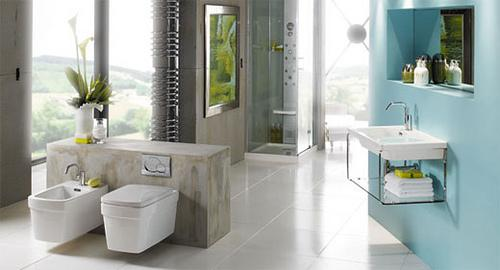Question: where was the photo taken?
Choices:
A. Downtown.
B. At zoo.
C. Bathroom.
D. On a boat.
Answer with the letter. Answer: C Question: what is the floor made of?
Choices:
A. Cement.
B. Grass.
C. Wood.
D. Tile.
Answer with the letter. Answer: D Question: who would fix the pipes in this room?
Choices:
A. Dad.
B. Plumber.
C. Me.
D. Professional.
Answer with the letter. Answer: B 